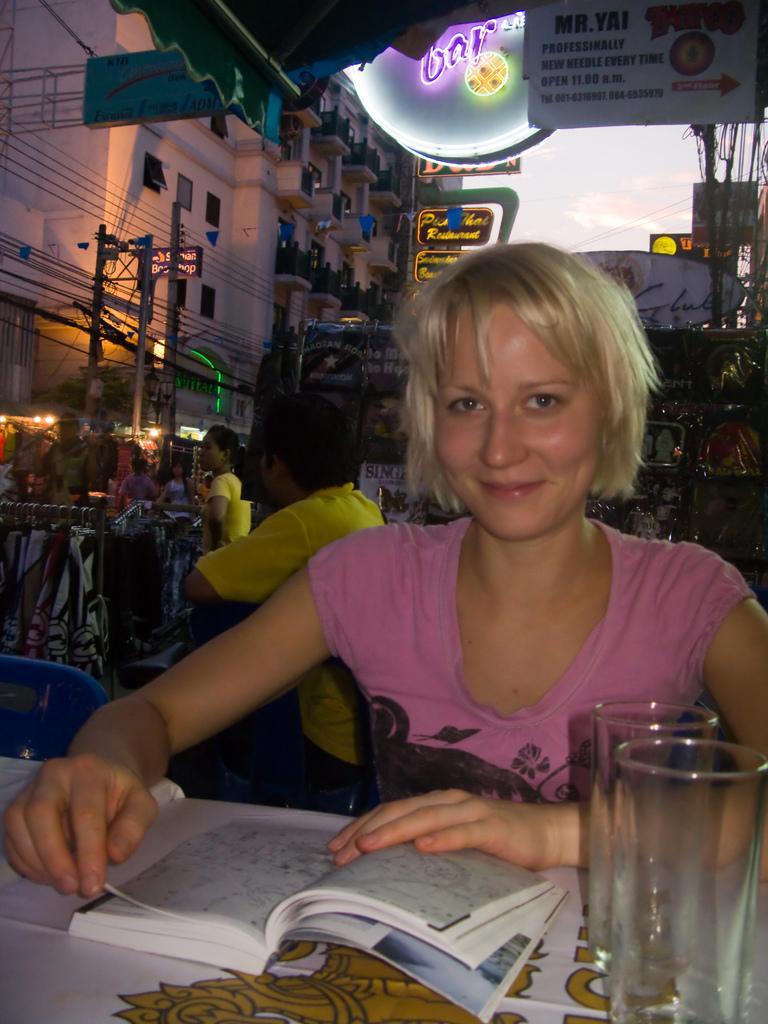Describe this image in one or two sentences. In this image, I can see the woman sitting and smiling. This is a table with a book, glasses and few other things on it. I can see a person sitting and few people standing. I think these are the clothes hanging to a hanger. I can see the buildings. These look like the name boards. I think these are the current poles with the current wires. 